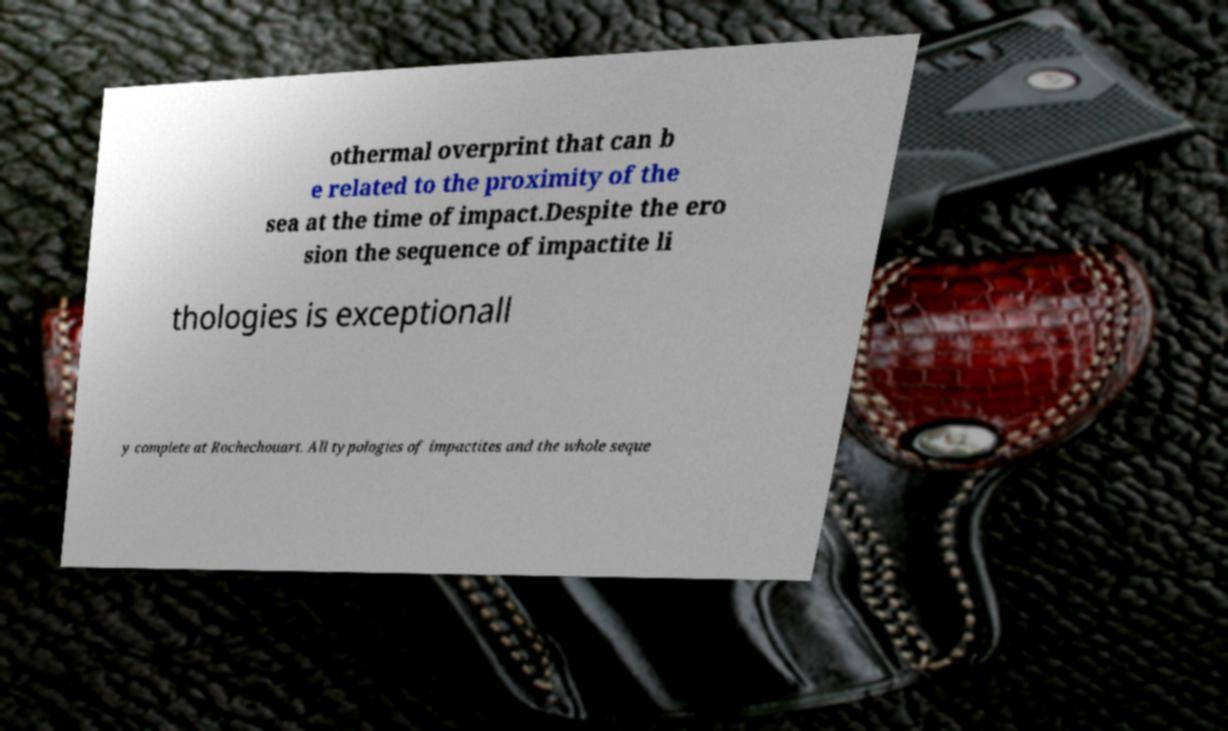Please identify and transcribe the text found in this image. othermal overprint that can b e related to the proximity of the sea at the time of impact.Despite the ero sion the sequence of impactite li thologies is exceptionall y complete at Rochechouart. All typologies of impactites and the whole seque 